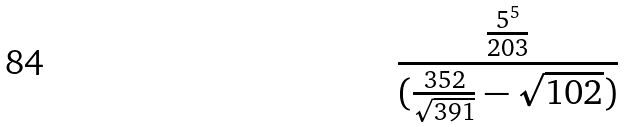Convert formula to latex. <formula><loc_0><loc_0><loc_500><loc_500>\frac { \frac { 5 ^ { 5 } } { 2 0 3 } } { ( \frac { 3 5 2 } { \sqrt { 3 9 1 } } - \sqrt { 1 0 2 } ) }</formula> 